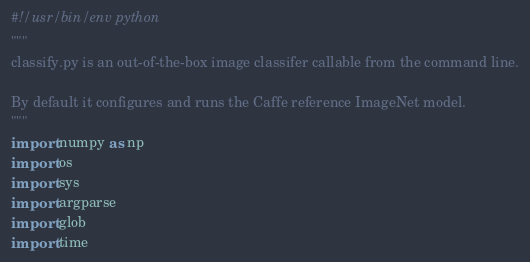Convert code to text. <code><loc_0><loc_0><loc_500><loc_500><_Python_>#!/usr/bin/env python
"""
classify.py is an out-of-the-box image classifer callable from the command line.

By default it configures and runs the Caffe reference ImageNet model.
"""
import numpy as np
import os
import sys
import argparse
import glob
import time
</code> 